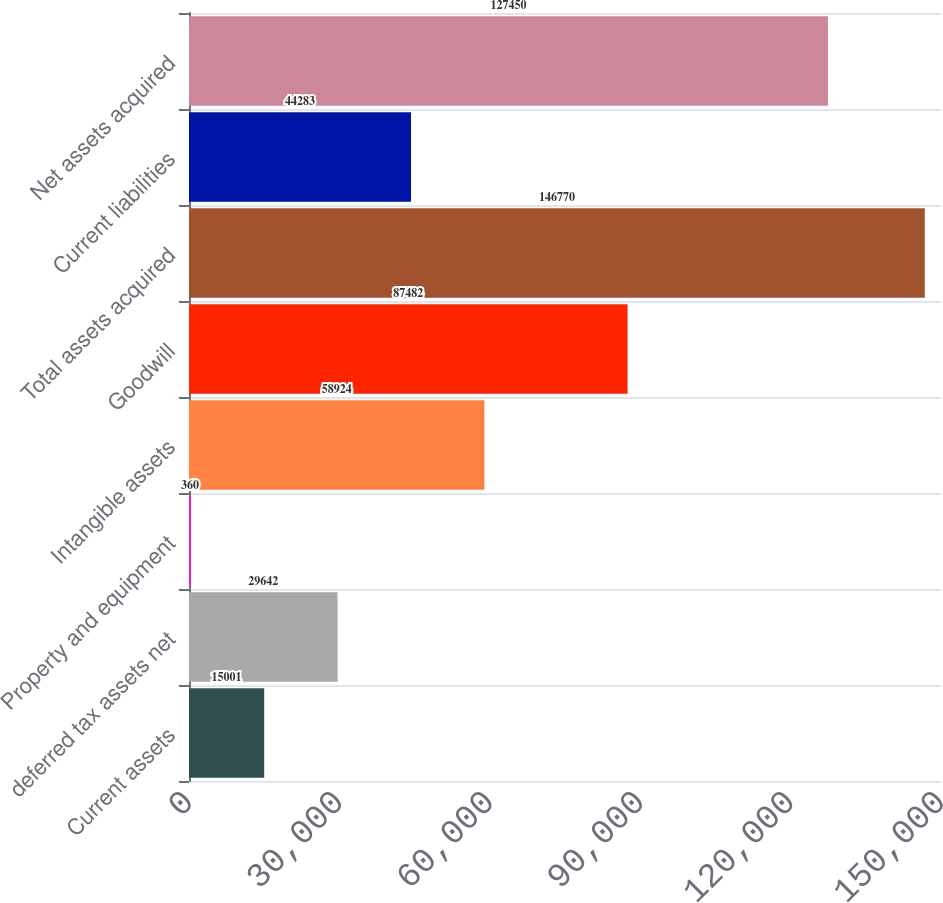Convert chart. <chart><loc_0><loc_0><loc_500><loc_500><bar_chart><fcel>Current assets<fcel>deferred tax assets net<fcel>Property and equipment<fcel>Intangible assets<fcel>Goodwill<fcel>Total assets acquired<fcel>Current liabilities<fcel>Net assets acquired<nl><fcel>15001<fcel>29642<fcel>360<fcel>58924<fcel>87482<fcel>146770<fcel>44283<fcel>127450<nl></chart> 